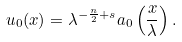<formula> <loc_0><loc_0><loc_500><loc_500>u _ { 0 } ( x ) = \lambda ^ { - \frac { n } { 2 } + s } a _ { 0 } \left ( \frac { x } { \lambda } \right ) .</formula> 